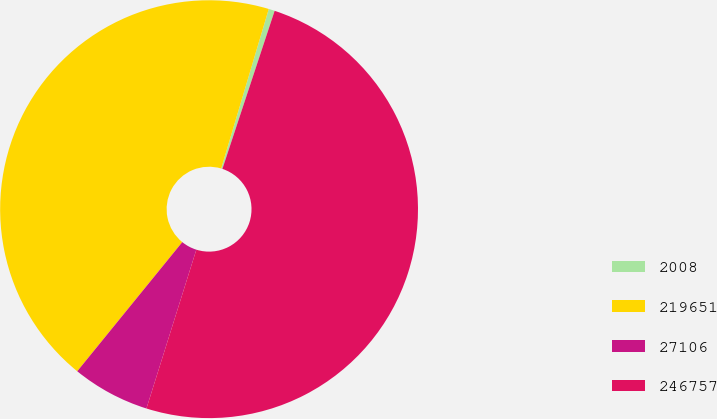<chart> <loc_0><loc_0><loc_500><loc_500><pie_chart><fcel>2008<fcel>219651<fcel>27106<fcel>246757<nl><fcel>0.47%<fcel>43.74%<fcel>6.02%<fcel>49.76%<nl></chart> 